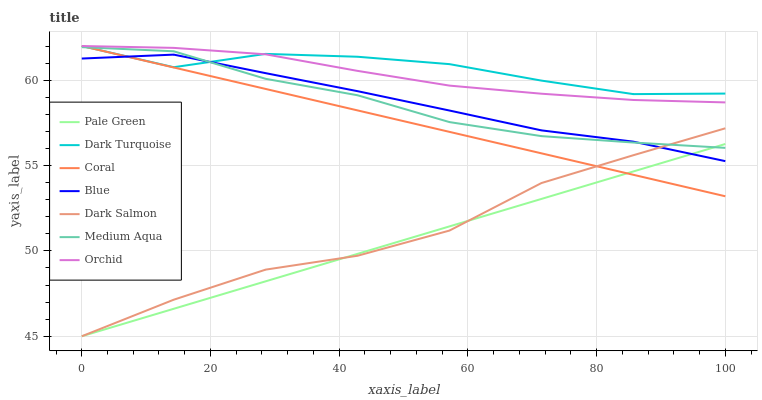Does Pale Green have the minimum area under the curve?
Answer yes or no. Yes. Does Dark Turquoise have the maximum area under the curve?
Answer yes or no. Yes. Does Coral have the minimum area under the curve?
Answer yes or no. No. Does Coral have the maximum area under the curve?
Answer yes or no. No. Is Coral the smoothest?
Answer yes or no. Yes. Is Dark Turquoise the roughest?
Answer yes or no. Yes. Is Dark Turquoise the smoothest?
Answer yes or no. No. Is Coral the roughest?
Answer yes or no. No. Does Dark Salmon have the lowest value?
Answer yes or no. Yes. Does Coral have the lowest value?
Answer yes or no. No. Does Orchid have the highest value?
Answer yes or no. Yes. Does Dark Salmon have the highest value?
Answer yes or no. No. Is Dark Salmon less than Orchid?
Answer yes or no. Yes. Is Orchid greater than Medium Aqua?
Answer yes or no. Yes. Does Medium Aqua intersect Pale Green?
Answer yes or no. Yes. Is Medium Aqua less than Pale Green?
Answer yes or no. No. Is Medium Aqua greater than Pale Green?
Answer yes or no. No. Does Dark Salmon intersect Orchid?
Answer yes or no. No. 